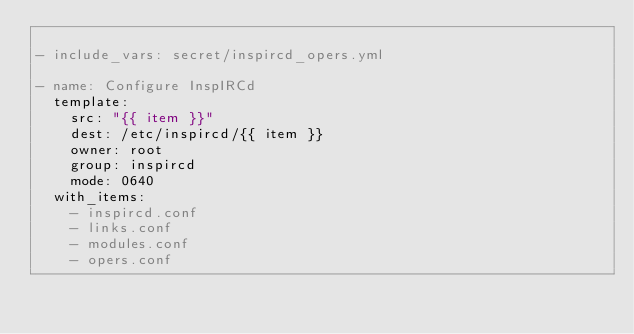<code> <loc_0><loc_0><loc_500><loc_500><_YAML_>
- include_vars: secret/inspircd_opers.yml

- name: Configure InspIRCd
  template:
    src: "{{ item }}"
    dest: /etc/inspircd/{{ item }}
    owner: root
    group: inspircd
    mode: 0640
  with_items:
    - inspircd.conf
    - links.conf
    - modules.conf
    - opers.conf</code> 